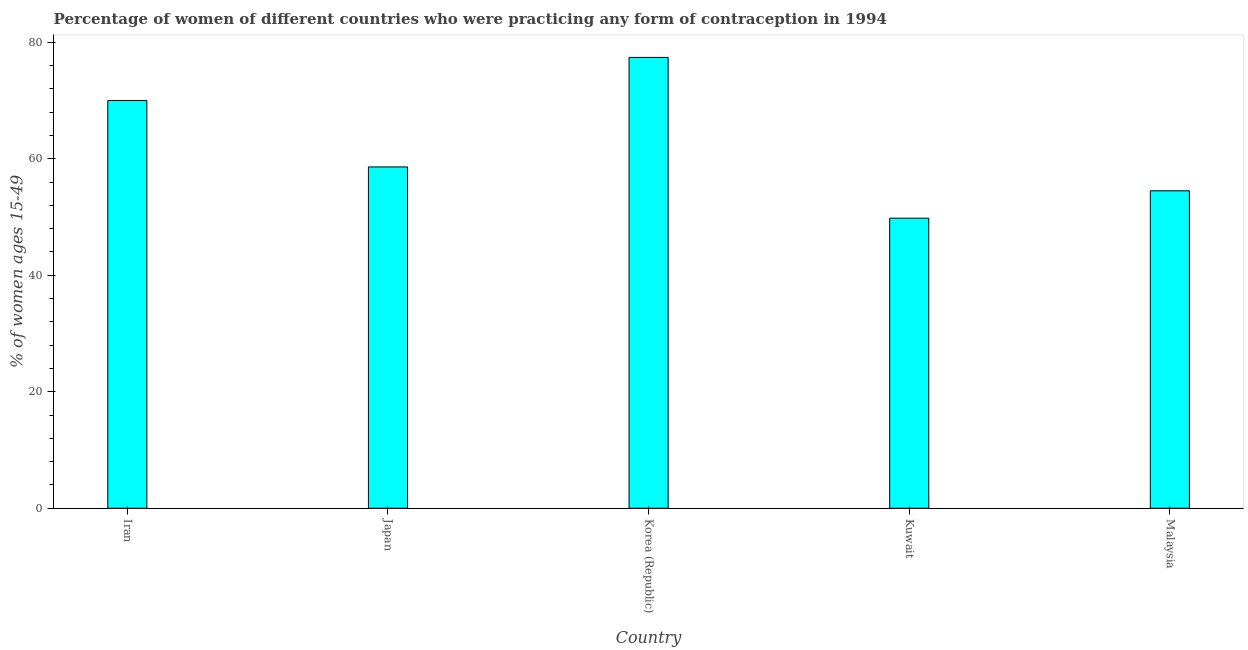What is the title of the graph?
Ensure brevity in your answer.  Percentage of women of different countries who were practicing any form of contraception in 1994. What is the label or title of the Y-axis?
Offer a terse response. % of women ages 15-49. What is the contraceptive prevalence in Iran?
Your answer should be very brief. 70. Across all countries, what is the maximum contraceptive prevalence?
Make the answer very short. 77.4. Across all countries, what is the minimum contraceptive prevalence?
Offer a very short reply. 49.8. In which country was the contraceptive prevalence maximum?
Make the answer very short. Korea (Republic). In which country was the contraceptive prevalence minimum?
Your answer should be compact. Kuwait. What is the sum of the contraceptive prevalence?
Your response must be concise. 310.3. What is the difference between the contraceptive prevalence in Iran and Kuwait?
Offer a terse response. 20.2. What is the average contraceptive prevalence per country?
Provide a short and direct response. 62.06. What is the median contraceptive prevalence?
Make the answer very short. 58.6. In how many countries, is the contraceptive prevalence greater than 24 %?
Your response must be concise. 5. What is the ratio of the contraceptive prevalence in Kuwait to that in Malaysia?
Ensure brevity in your answer.  0.91. Is the contraceptive prevalence in Japan less than that in Malaysia?
Provide a short and direct response. No. What is the difference between the highest and the second highest contraceptive prevalence?
Provide a succinct answer. 7.4. Is the sum of the contraceptive prevalence in Iran and Kuwait greater than the maximum contraceptive prevalence across all countries?
Your answer should be very brief. Yes. What is the difference between the highest and the lowest contraceptive prevalence?
Keep it short and to the point. 27.6. In how many countries, is the contraceptive prevalence greater than the average contraceptive prevalence taken over all countries?
Keep it short and to the point. 2. How many bars are there?
Provide a short and direct response. 5. Are all the bars in the graph horizontal?
Offer a terse response. No. How many countries are there in the graph?
Give a very brief answer. 5. What is the difference between two consecutive major ticks on the Y-axis?
Offer a very short reply. 20. What is the % of women ages 15-49 of Iran?
Provide a short and direct response. 70. What is the % of women ages 15-49 of Japan?
Make the answer very short. 58.6. What is the % of women ages 15-49 of Korea (Republic)?
Provide a short and direct response. 77.4. What is the % of women ages 15-49 in Kuwait?
Ensure brevity in your answer.  49.8. What is the % of women ages 15-49 of Malaysia?
Offer a very short reply. 54.5. What is the difference between the % of women ages 15-49 in Iran and Korea (Republic)?
Ensure brevity in your answer.  -7.4. What is the difference between the % of women ages 15-49 in Iran and Kuwait?
Ensure brevity in your answer.  20.2. What is the difference between the % of women ages 15-49 in Iran and Malaysia?
Provide a short and direct response. 15.5. What is the difference between the % of women ages 15-49 in Japan and Korea (Republic)?
Offer a very short reply. -18.8. What is the difference between the % of women ages 15-49 in Japan and Kuwait?
Make the answer very short. 8.8. What is the difference between the % of women ages 15-49 in Korea (Republic) and Kuwait?
Give a very brief answer. 27.6. What is the difference between the % of women ages 15-49 in Korea (Republic) and Malaysia?
Give a very brief answer. 22.9. What is the difference between the % of women ages 15-49 in Kuwait and Malaysia?
Provide a succinct answer. -4.7. What is the ratio of the % of women ages 15-49 in Iran to that in Japan?
Your answer should be compact. 1.2. What is the ratio of the % of women ages 15-49 in Iran to that in Korea (Republic)?
Provide a short and direct response. 0.9. What is the ratio of the % of women ages 15-49 in Iran to that in Kuwait?
Your response must be concise. 1.41. What is the ratio of the % of women ages 15-49 in Iran to that in Malaysia?
Your answer should be compact. 1.28. What is the ratio of the % of women ages 15-49 in Japan to that in Korea (Republic)?
Offer a very short reply. 0.76. What is the ratio of the % of women ages 15-49 in Japan to that in Kuwait?
Provide a succinct answer. 1.18. What is the ratio of the % of women ages 15-49 in Japan to that in Malaysia?
Your response must be concise. 1.07. What is the ratio of the % of women ages 15-49 in Korea (Republic) to that in Kuwait?
Make the answer very short. 1.55. What is the ratio of the % of women ages 15-49 in Korea (Republic) to that in Malaysia?
Your answer should be very brief. 1.42. What is the ratio of the % of women ages 15-49 in Kuwait to that in Malaysia?
Ensure brevity in your answer.  0.91. 